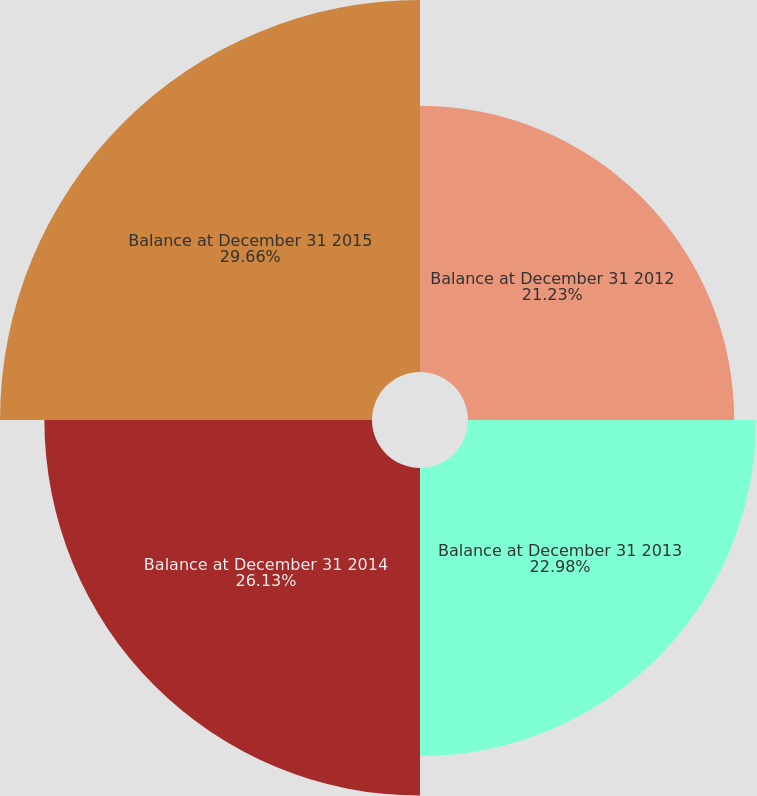Convert chart to OTSL. <chart><loc_0><loc_0><loc_500><loc_500><pie_chart><fcel>Balance at December 31 2012<fcel>Balance at December 31 2013<fcel>Balance at December 31 2014<fcel>Balance at December 31 2015<nl><fcel>21.23%<fcel>22.98%<fcel>26.13%<fcel>29.67%<nl></chart> 